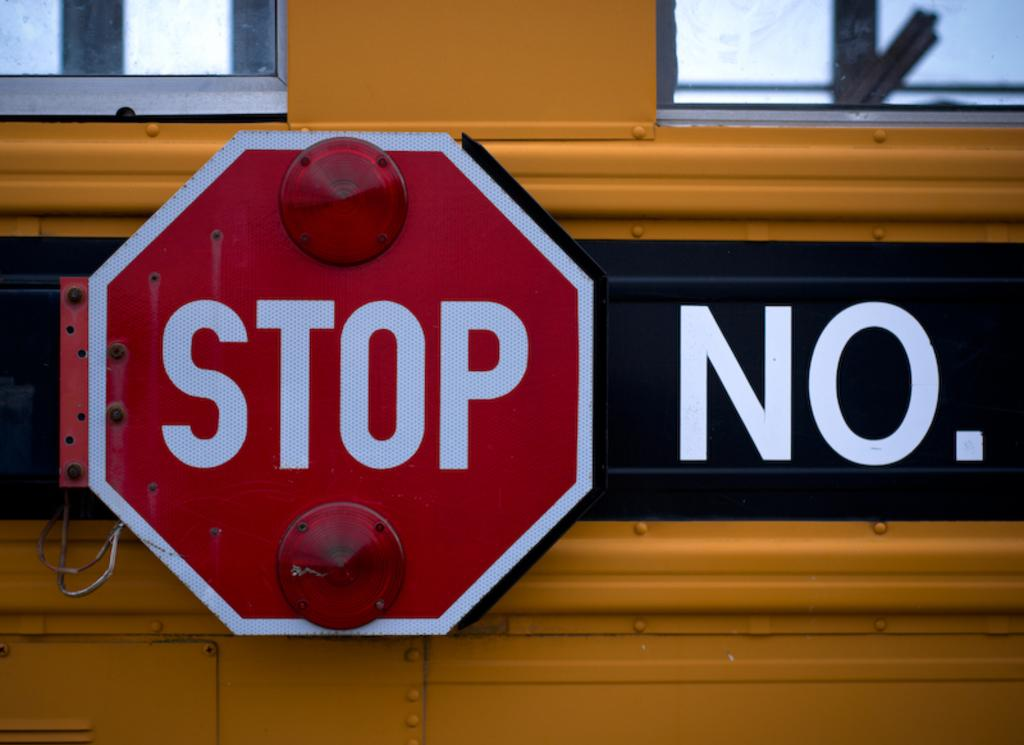<image>
Create a compact narrative representing the image presented. A red stop sign attached to a school bus has the word "no" next to it. 